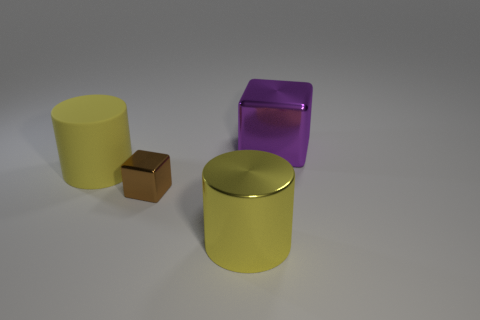Add 2 big purple cubes. How many objects exist? 6 Add 2 big metallic cubes. How many big metallic cubes are left? 3 Add 2 tiny metal cubes. How many tiny metal cubes exist? 3 Subtract 0 cyan balls. How many objects are left? 4 Subtract all tiny green metallic blocks. Subtract all brown shiny things. How many objects are left? 3 